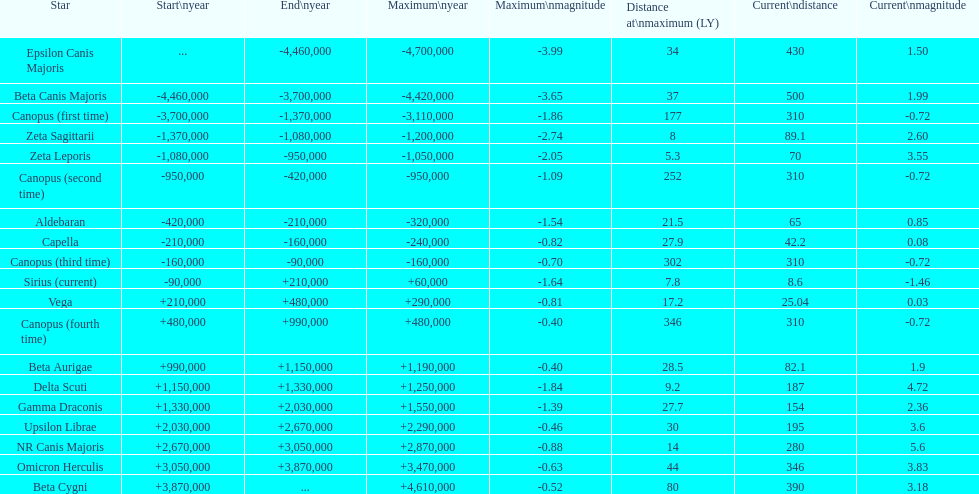How many stars have a magnitude greater than zero? 14. 